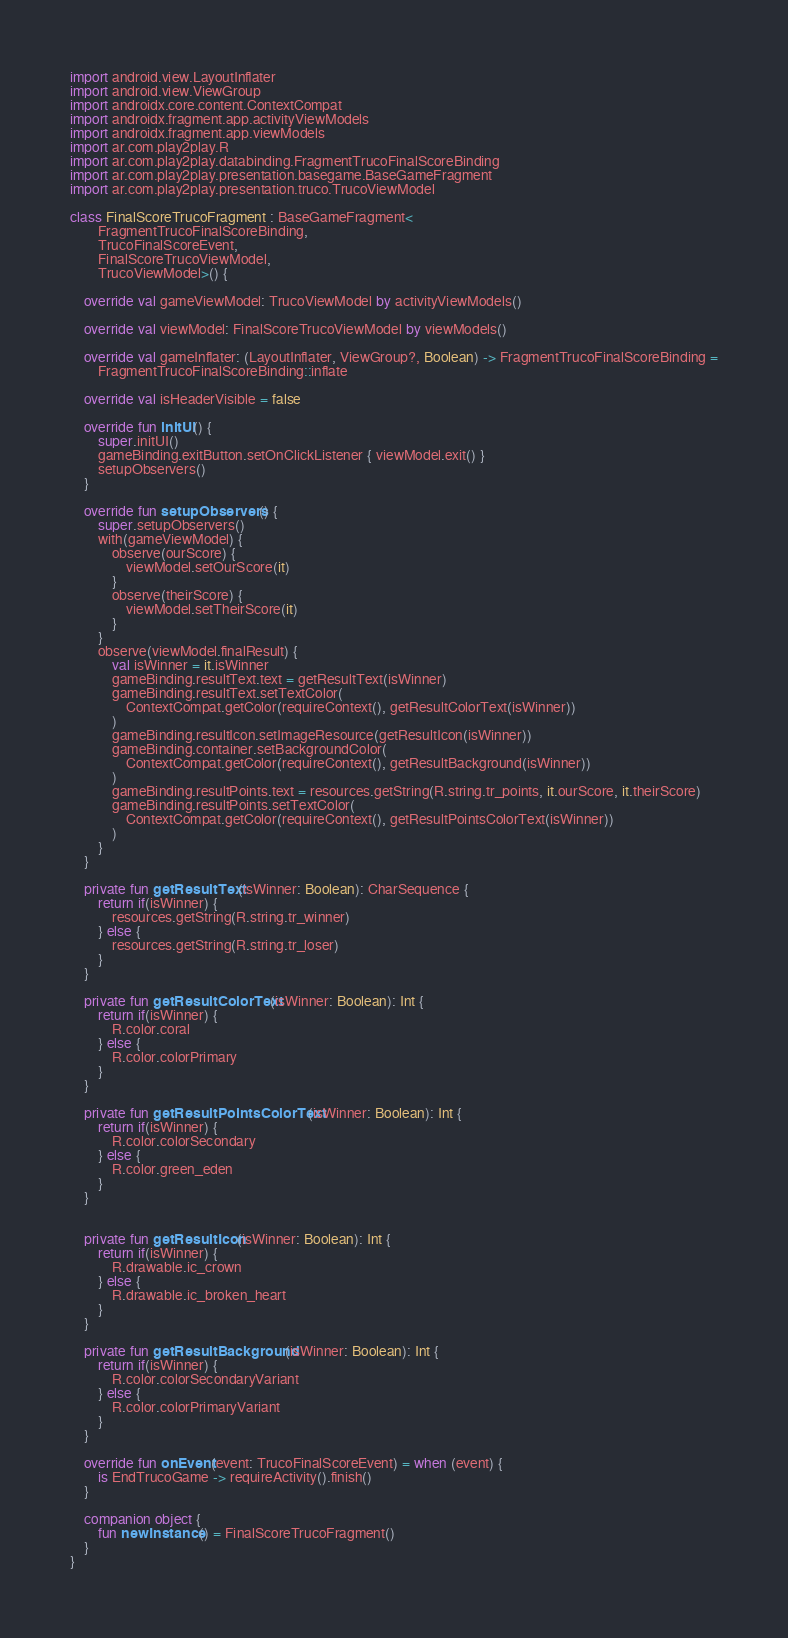Convert code to text. <code><loc_0><loc_0><loc_500><loc_500><_Kotlin_>import android.view.LayoutInflater
import android.view.ViewGroup
import androidx.core.content.ContextCompat
import androidx.fragment.app.activityViewModels
import androidx.fragment.app.viewModels
import ar.com.play2play.R
import ar.com.play2play.databinding.FragmentTrucoFinalScoreBinding
import ar.com.play2play.presentation.basegame.BaseGameFragment
import ar.com.play2play.presentation.truco.TrucoViewModel

class FinalScoreTrucoFragment : BaseGameFragment<
        FragmentTrucoFinalScoreBinding,
        TrucoFinalScoreEvent,
        FinalScoreTrucoViewModel,
        TrucoViewModel>() {

    override val gameViewModel: TrucoViewModel by activityViewModels()

    override val viewModel: FinalScoreTrucoViewModel by viewModels()

    override val gameInflater: (LayoutInflater, ViewGroup?, Boolean) -> FragmentTrucoFinalScoreBinding =
        FragmentTrucoFinalScoreBinding::inflate

    override val isHeaderVisible = false

    override fun initUI() {
        super.initUI()
        gameBinding.exitButton.setOnClickListener { viewModel.exit() }
        setupObservers()
    }

    override fun setupObservers() {
        super.setupObservers()
        with(gameViewModel) {
            observe(ourScore) {
                viewModel.setOurScore(it)
            }
            observe(theirScore) {
                viewModel.setTheirScore(it)
            }
        }
        observe(viewModel.finalResult) {
            val isWinner = it.isWinner
            gameBinding.resultText.text = getResultText(isWinner)
            gameBinding.resultText.setTextColor(
                ContextCompat.getColor(requireContext(), getResultColorText(isWinner))
            )
            gameBinding.resultIcon.setImageResource(getResultIcon(isWinner))
            gameBinding.container.setBackgroundColor(
                ContextCompat.getColor(requireContext(), getResultBackground(isWinner))
            )
            gameBinding.resultPoints.text = resources.getString(R.string.tr_points, it.ourScore, it.theirScore)
            gameBinding.resultPoints.setTextColor(
                ContextCompat.getColor(requireContext(), getResultPointsColorText(isWinner))
            )
        }
    }

    private fun getResultText(isWinner: Boolean): CharSequence {
        return if(isWinner) {
            resources.getString(R.string.tr_winner)
        } else {
            resources.getString(R.string.tr_loser)
        }
    }

    private fun getResultColorText(isWinner: Boolean): Int {
        return if(isWinner) {
            R.color.coral
        } else {
            R.color.colorPrimary
        }
    }

    private fun getResultPointsColorText(isWinner: Boolean): Int {
        return if(isWinner) {
            R.color.colorSecondary
        } else {
            R.color.green_eden
        }
    }


    private fun getResultIcon(isWinner: Boolean): Int {
        return if(isWinner) {
            R.drawable.ic_crown
        } else {
            R.drawable.ic_broken_heart
        }
    }

    private fun getResultBackground(isWinner: Boolean): Int {
        return if(isWinner) {
            R.color.colorSecondaryVariant
        } else {
            R.color.colorPrimaryVariant
        }
    }

    override fun onEvent(event: TrucoFinalScoreEvent) = when (event) {
        is EndTrucoGame -> requireActivity().finish()
    }

    companion object {
        fun newInstance() = FinalScoreTrucoFragment()
    }
}
</code> 